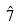<formula> <loc_0><loc_0><loc_500><loc_500>\hat { 7 }</formula> 